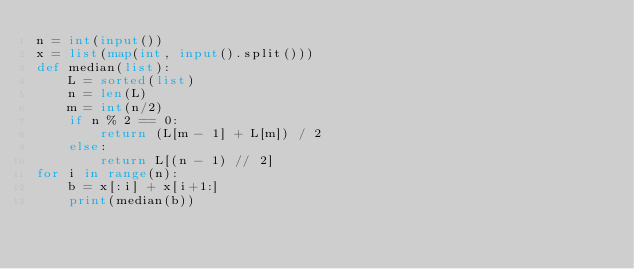<code> <loc_0><loc_0><loc_500><loc_500><_Python_>n = int(input())
x = list(map(int, input().split()))
def median(list):
    L = sorted(list)
    n = len(L)
    m = int(n/2)
    if n % 2 == 0:
        return (L[m - 1] + L[m]) / 2
    else:
        return L[(n - 1) // 2]
for i in range(n):
    b = x[:i] + x[i+1:]
    print(median(b))</code> 